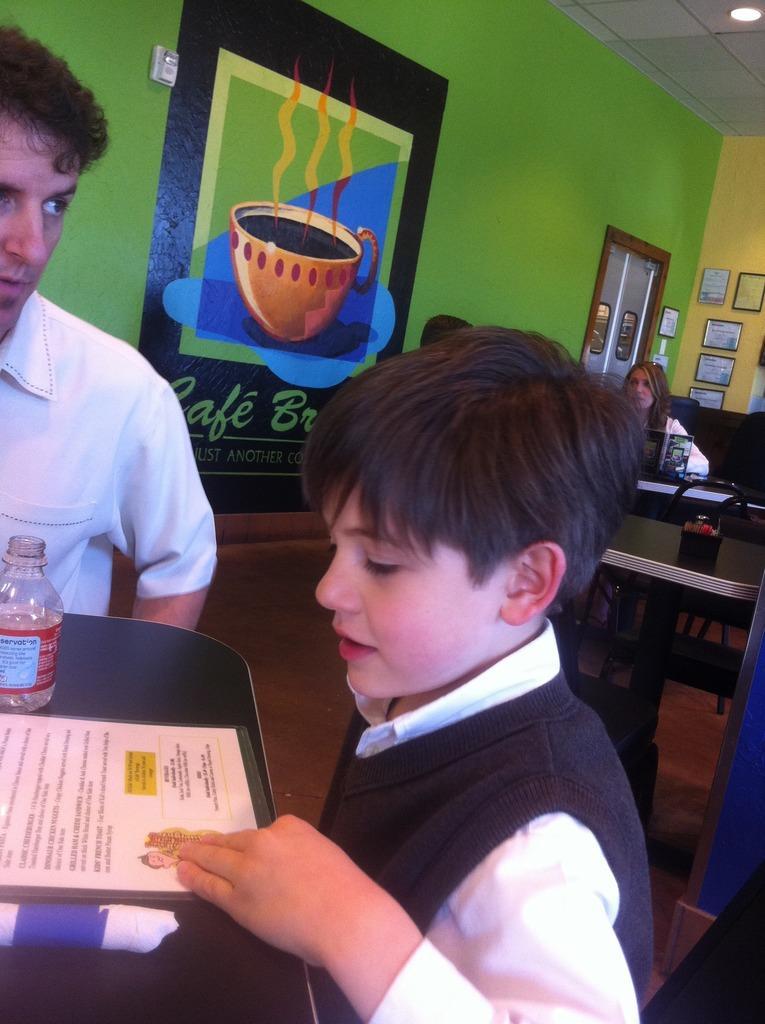Could you give a brief overview of what you see in this image? This picture shows the inner view of a room. There are some frames hanged on the wall, one light attached to the ceiling, some text with images painted on the green wall and one object attached on the green wall. Some people sitting on the chairs, one glass door, some objects are on the surface, some chairs, tables and some different objects are on the tables. 